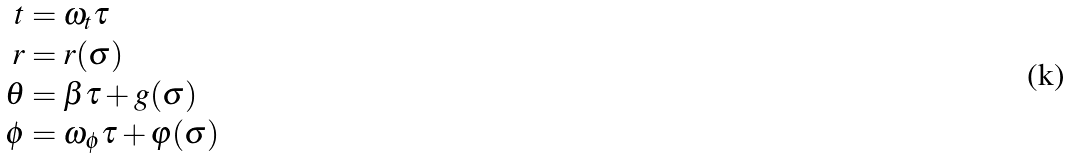Convert formula to latex. <formula><loc_0><loc_0><loc_500><loc_500>t & = \omega _ { t } \tau \\ r & = r ( \sigma ) \\ \theta & = \beta \tau + g ( \sigma ) \\ \phi & = \omega _ { \phi } \tau + \varphi ( \sigma )</formula> 